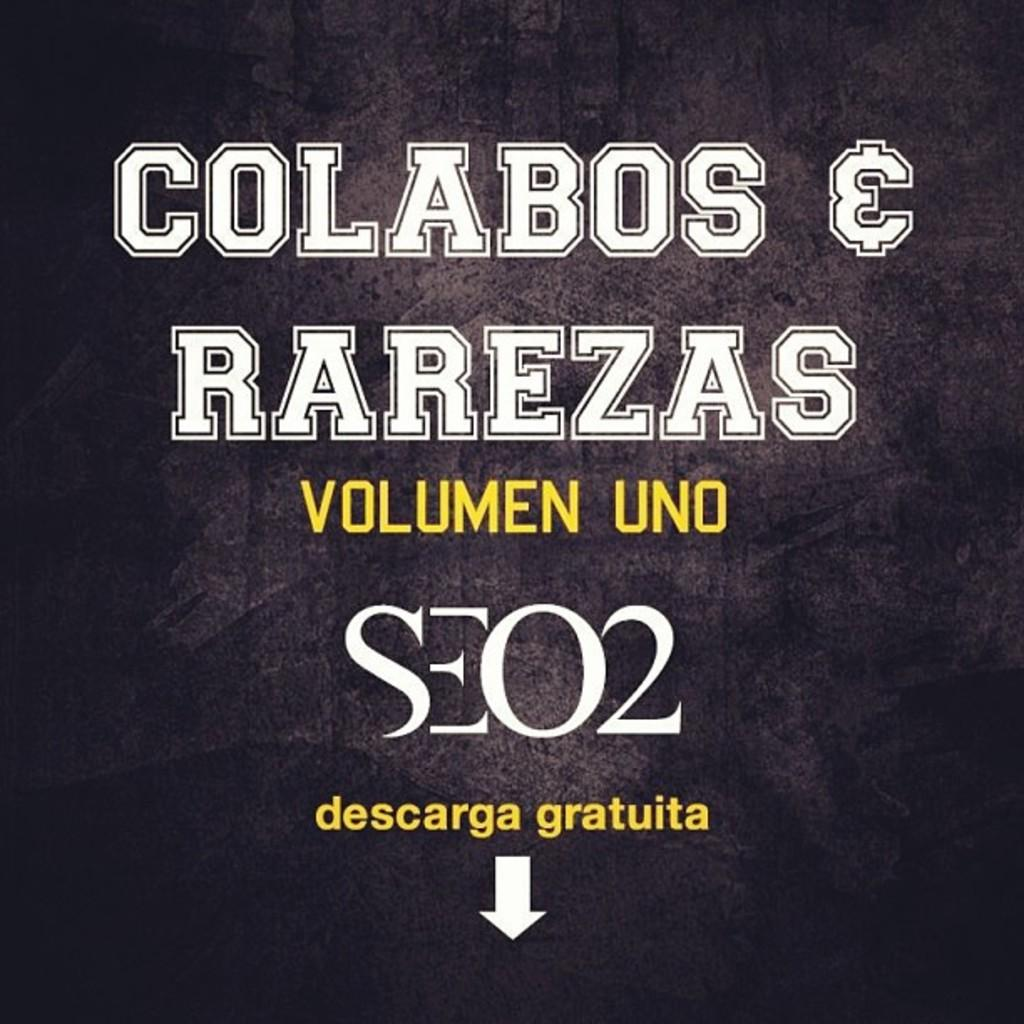<image>
Give a short and clear explanation of the subsequent image. A black and yellow flyer that says the words Volumen Uno in the middle. 